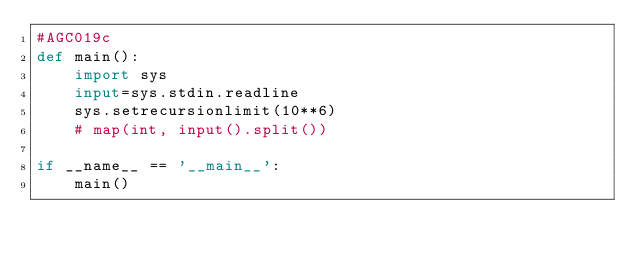Convert code to text. <code><loc_0><loc_0><loc_500><loc_500><_Python_>#AGC019c
def main():
    import sys
    input=sys.stdin.readline
    sys.setrecursionlimit(10**6)
    # map(int, input().split())

if __name__ == '__main__':
    main()</code> 